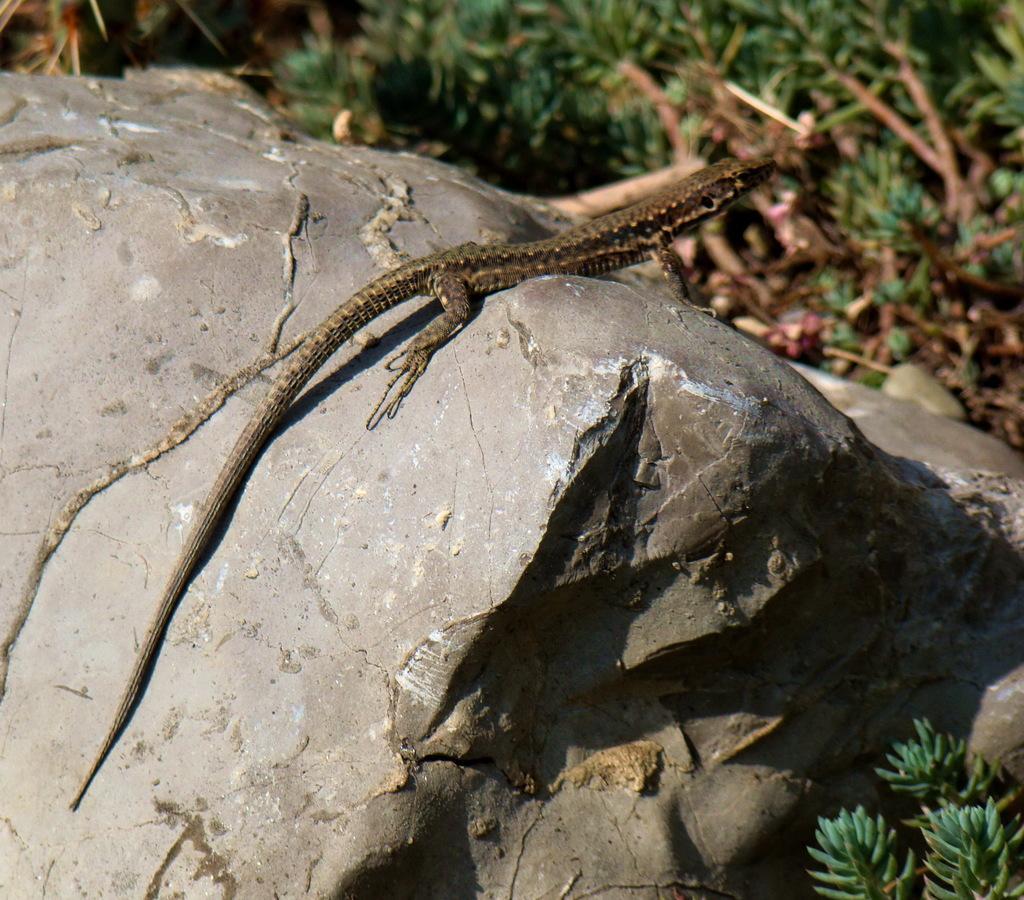Please provide a concise description of this image. In the middle there is one reptile which is on this rock. 